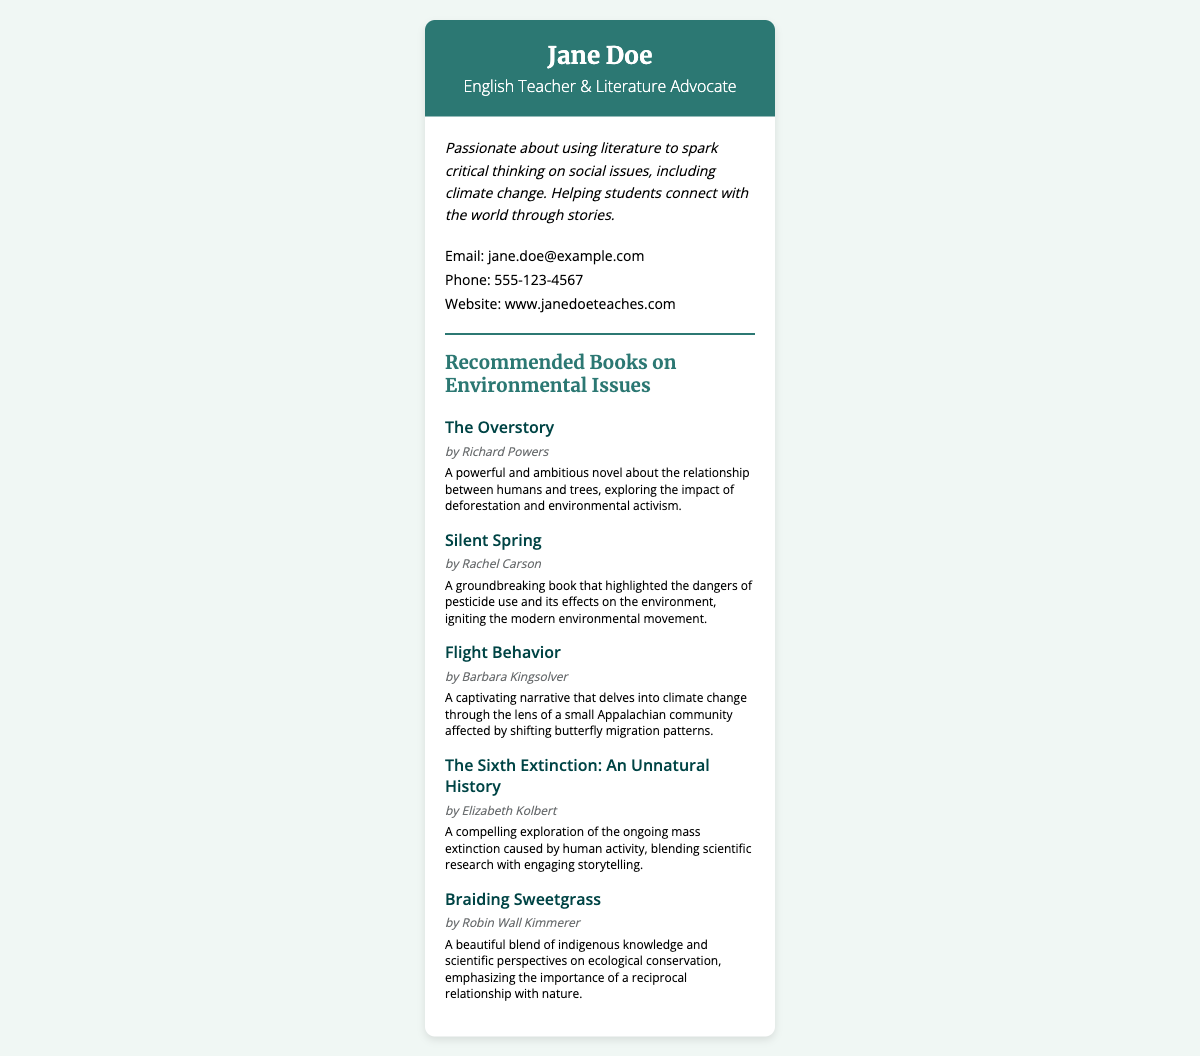What is the name of the English teacher? The name listed in the document is at the top of the card under the header section.
Answer: Jane Doe What is the email provided in the contact information? The email address can be found in the contact info section of the card.
Answer: jane.doe@example.com Which book is authored by Richard Powers? The book title is mentioned in the list of recommended books along with the author's name.
Answer: The Overstory How many recommended books are listed on the card? The number of books can be counted in the book list section.
Answer: Five What is the primary theme of "Silent Spring"? The theme is specified in the book's descriptive text under the title.
Answer: Dangers of pesticide use What literary role does Jane Doe claim to advocate for? The document states her role in the header and also describes it in the bio section.
Answer: Literature Advocate What website is associated with Jane Doe? The website can be found towards the end of the contact information section.
Answer: www.janedoeteaches.com What is the significance of "Braiding Sweetgrass"? The book's description highlights its focus and perspective.
Answer: Indigenous knowledge and ecological conservation What profession does Jane Doe have besides being a literature advocate? The profession is clearly stated in the header of the card.
Answer: English Teacher 